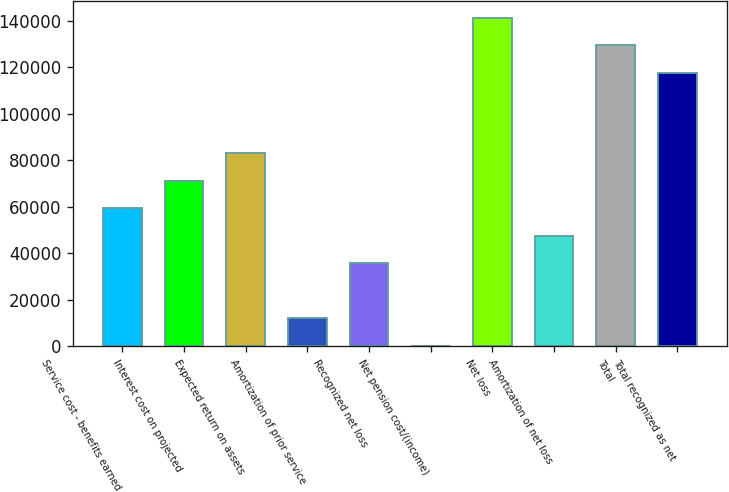<chart> <loc_0><loc_0><loc_500><loc_500><bar_chart><fcel>Service cost - benefits earned<fcel>Interest cost on projected<fcel>Expected return on assets<fcel>Amortization of prior service<fcel>Recognized net loss<fcel>Net pension cost/(income)<fcel>Net loss<fcel>Amortization of net loss<fcel>Total<fcel>Total recognized as net<nl><fcel>59505.5<fcel>71365.2<fcel>83224.9<fcel>12066.7<fcel>35786.1<fcel>207<fcel>141417<fcel>47645.8<fcel>129558<fcel>117698<nl></chart> 